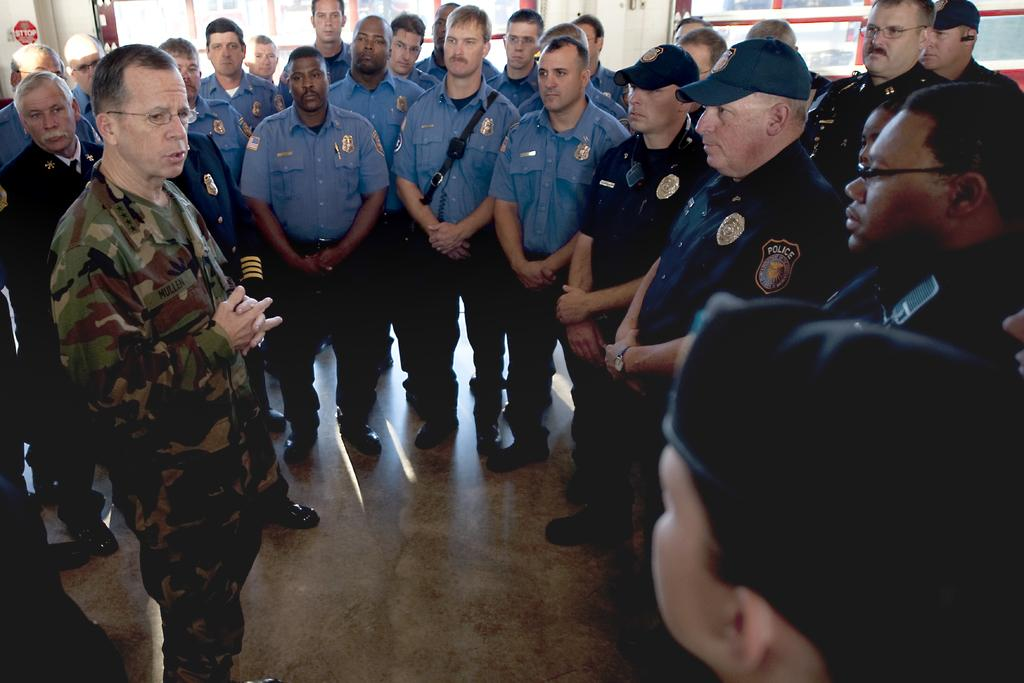What is the main subject of the image? The main subject of the image is a group of people. Can you describe any specific features of the people in the group? Some people in the group are wearing spectacles, and some are wearing caps. What type of smoke can be seen coming from the caps in the image? There is no smoke present in the image; the people in the group are wearing caps and spectacles. Can you tell me how many mothers are visible in the image? The provided facts do not mention any mothers in the image, so it cannot be determined from the information given. 